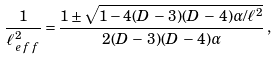Convert formula to latex. <formula><loc_0><loc_0><loc_500><loc_500>\frac { 1 } { \ell _ { \, e \, f \, f } ^ { 2 } } = \frac { 1 \pm \sqrt { 1 - 4 ( D \, - \, 3 ) ( D \, - \, 4 ) \alpha / \ell ^ { 2 } } } { 2 ( D \, - \, 3 ) ( D \, - \, 4 ) \alpha } \, ,</formula> 